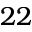Convert formula to latex. <formula><loc_0><loc_0><loc_500><loc_500>2 2</formula> 